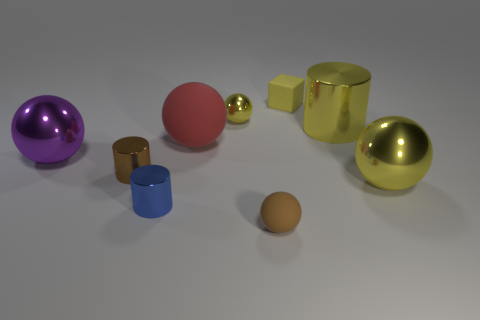There is a tiny metallic sphere; is its color the same as the small cube on the left side of the big yellow cylinder?
Provide a short and direct response. Yes. The tiny cube is what color?
Ensure brevity in your answer.  Yellow. Is there anything else that has the same shape as the red thing?
Your response must be concise. Yes. There is a small metal thing that is the same shape as the large matte thing; what color is it?
Ensure brevity in your answer.  Yellow. Is the shape of the large purple object the same as the large rubber thing?
Give a very brief answer. Yes. How many balls are either large brown rubber things or small yellow shiny things?
Ensure brevity in your answer.  1. What is the color of the big cylinder that is the same material as the small yellow ball?
Your response must be concise. Yellow. There is a matte object that is in front of the purple metal sphere; does it have the same size as the big red rubber ball?
Your response must be concise. No. Are the tiny brown cylinder and the small ball that is in front of the brown metal cylinder made of the same material?
Offer a very short reply. No. What color is the rubber ball on the right side of the big red rubber object?
Offer a terse response. Brown. 